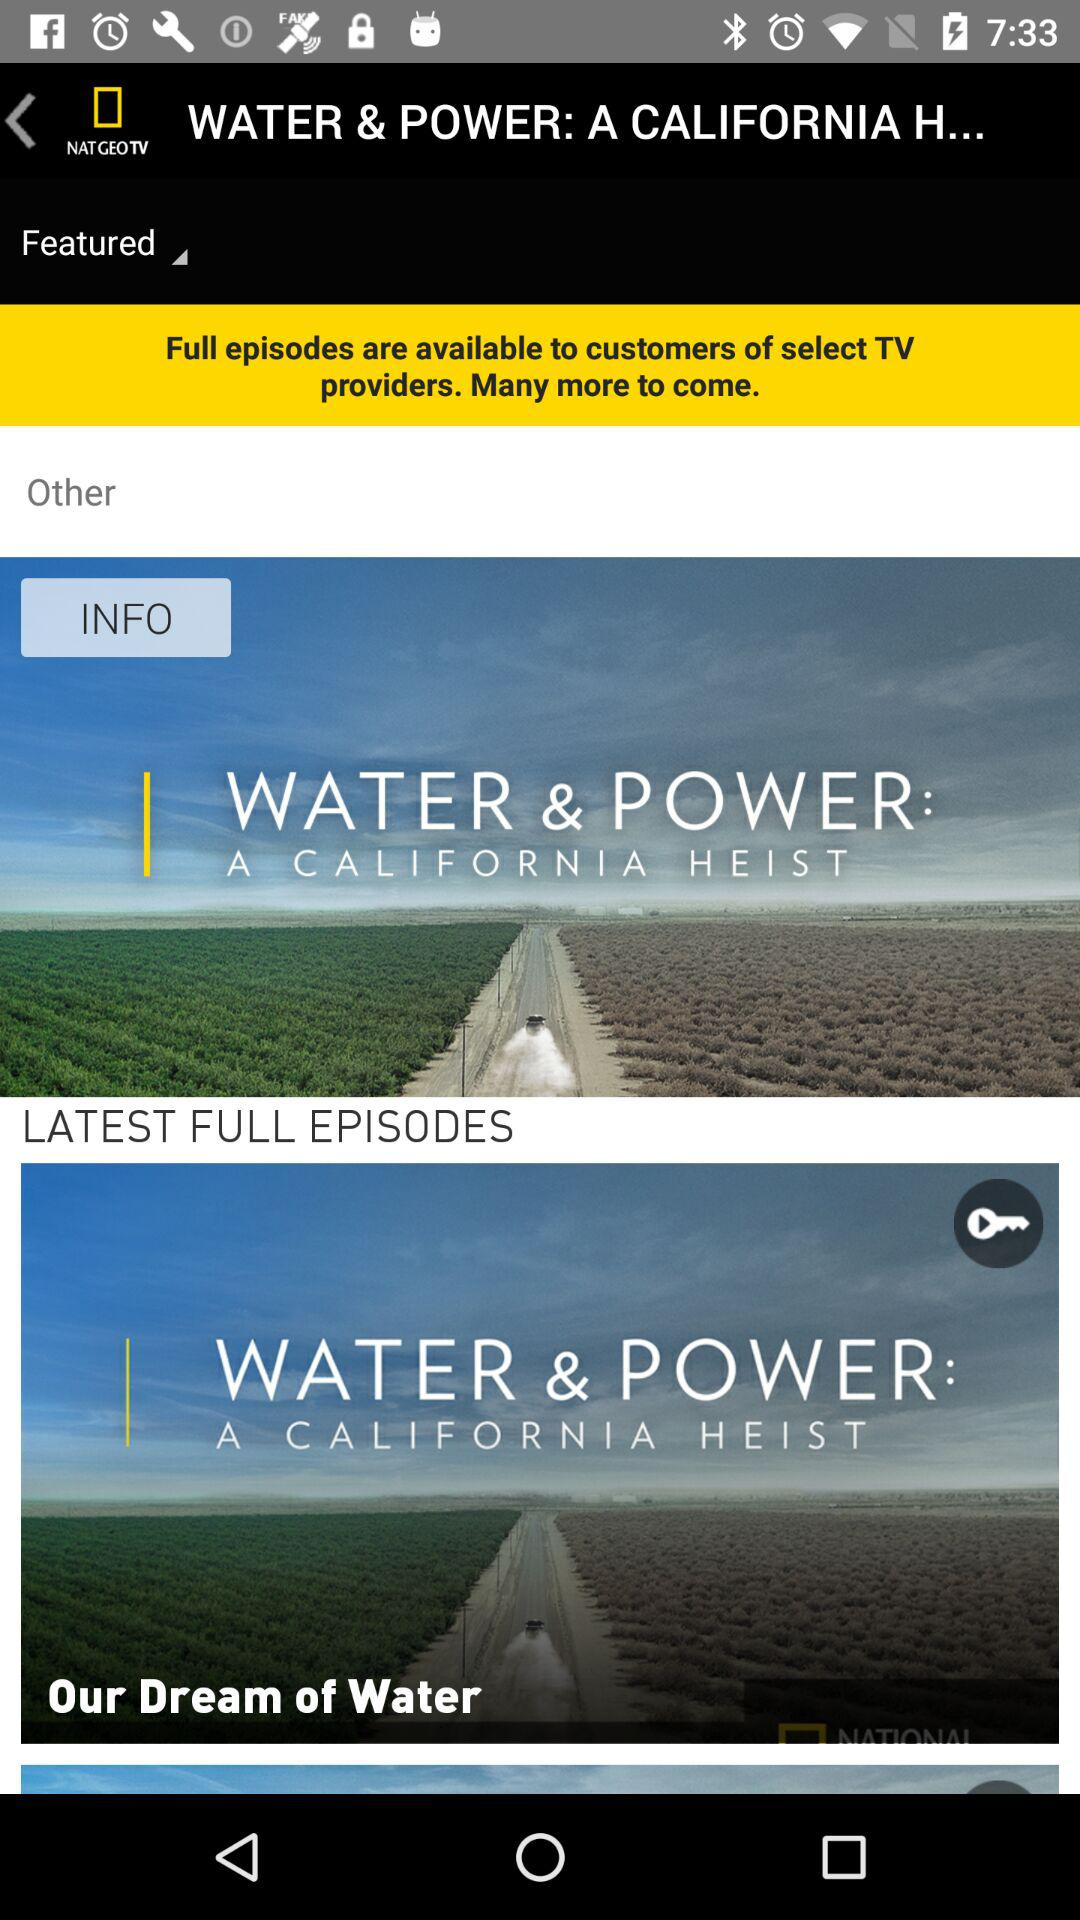Which video sorting method was selected? The selected video sorting method was "Featured". 